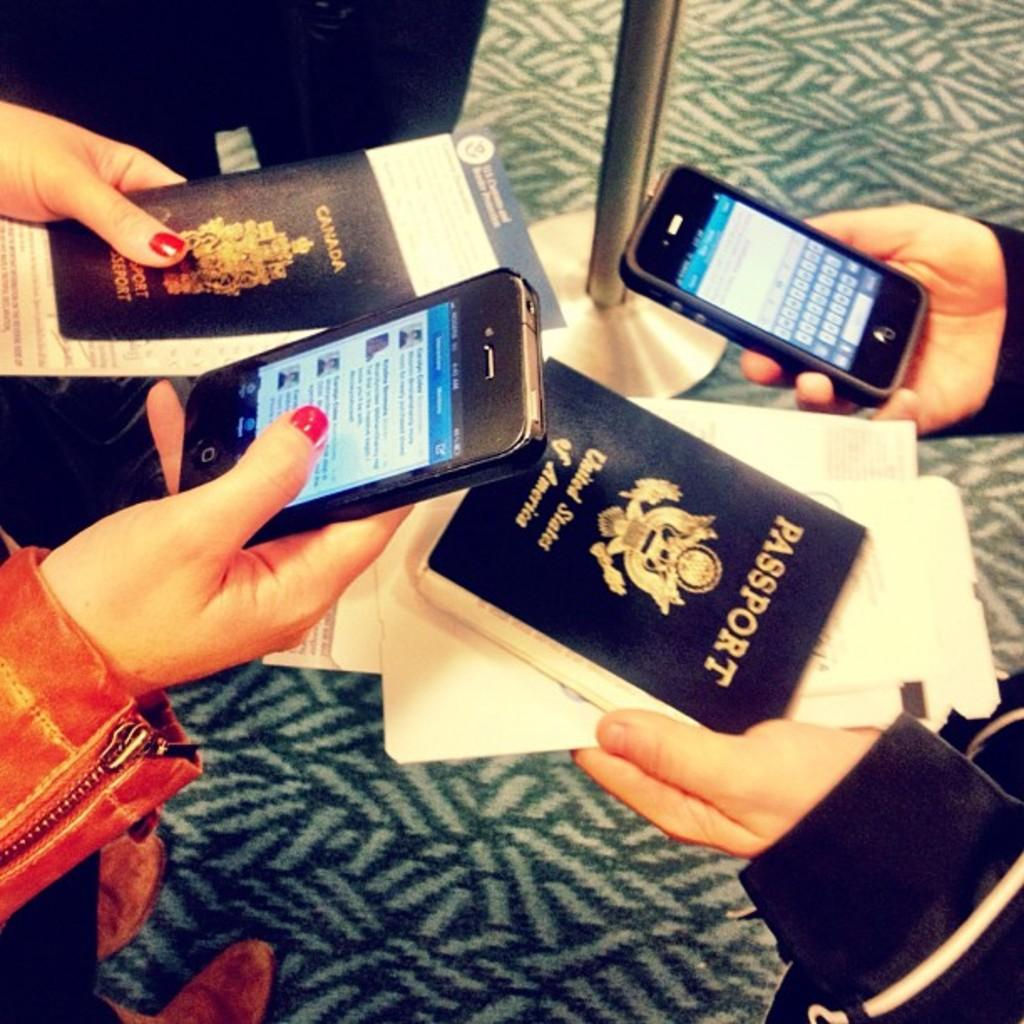<image>
Relay a brief, clear account of the picture shown. A group of people are holding cell phones and booklets that say Passport. 